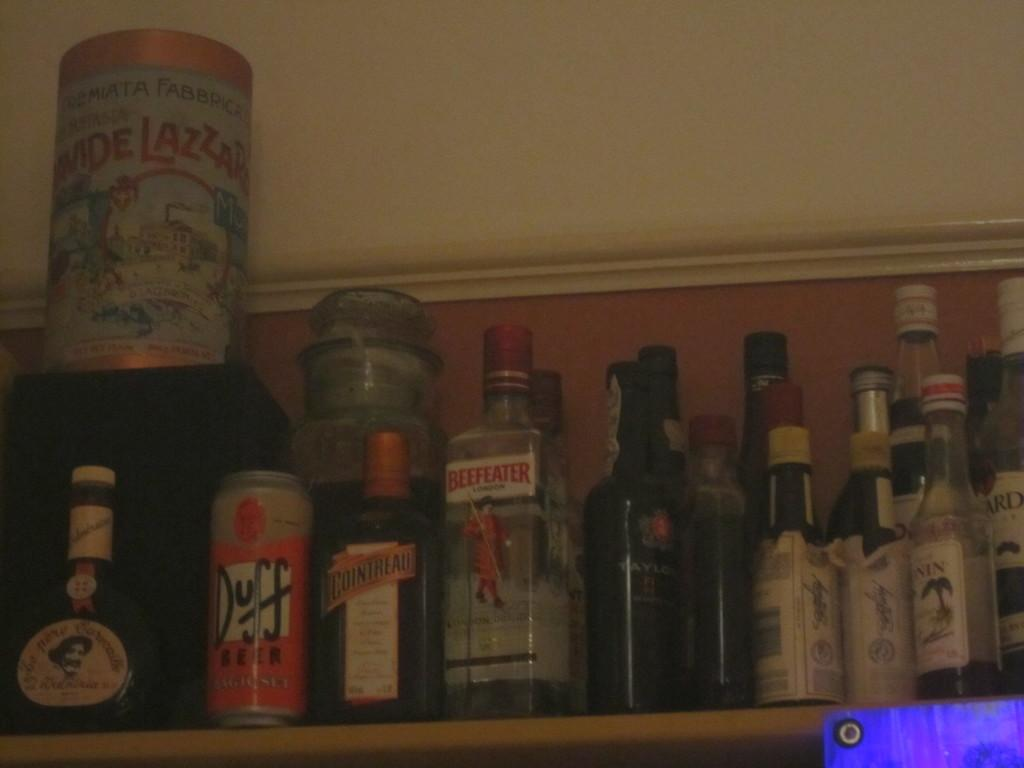<image>
Summarize the visual content of the image. a bunch of bottles, one has beefeatere on it 